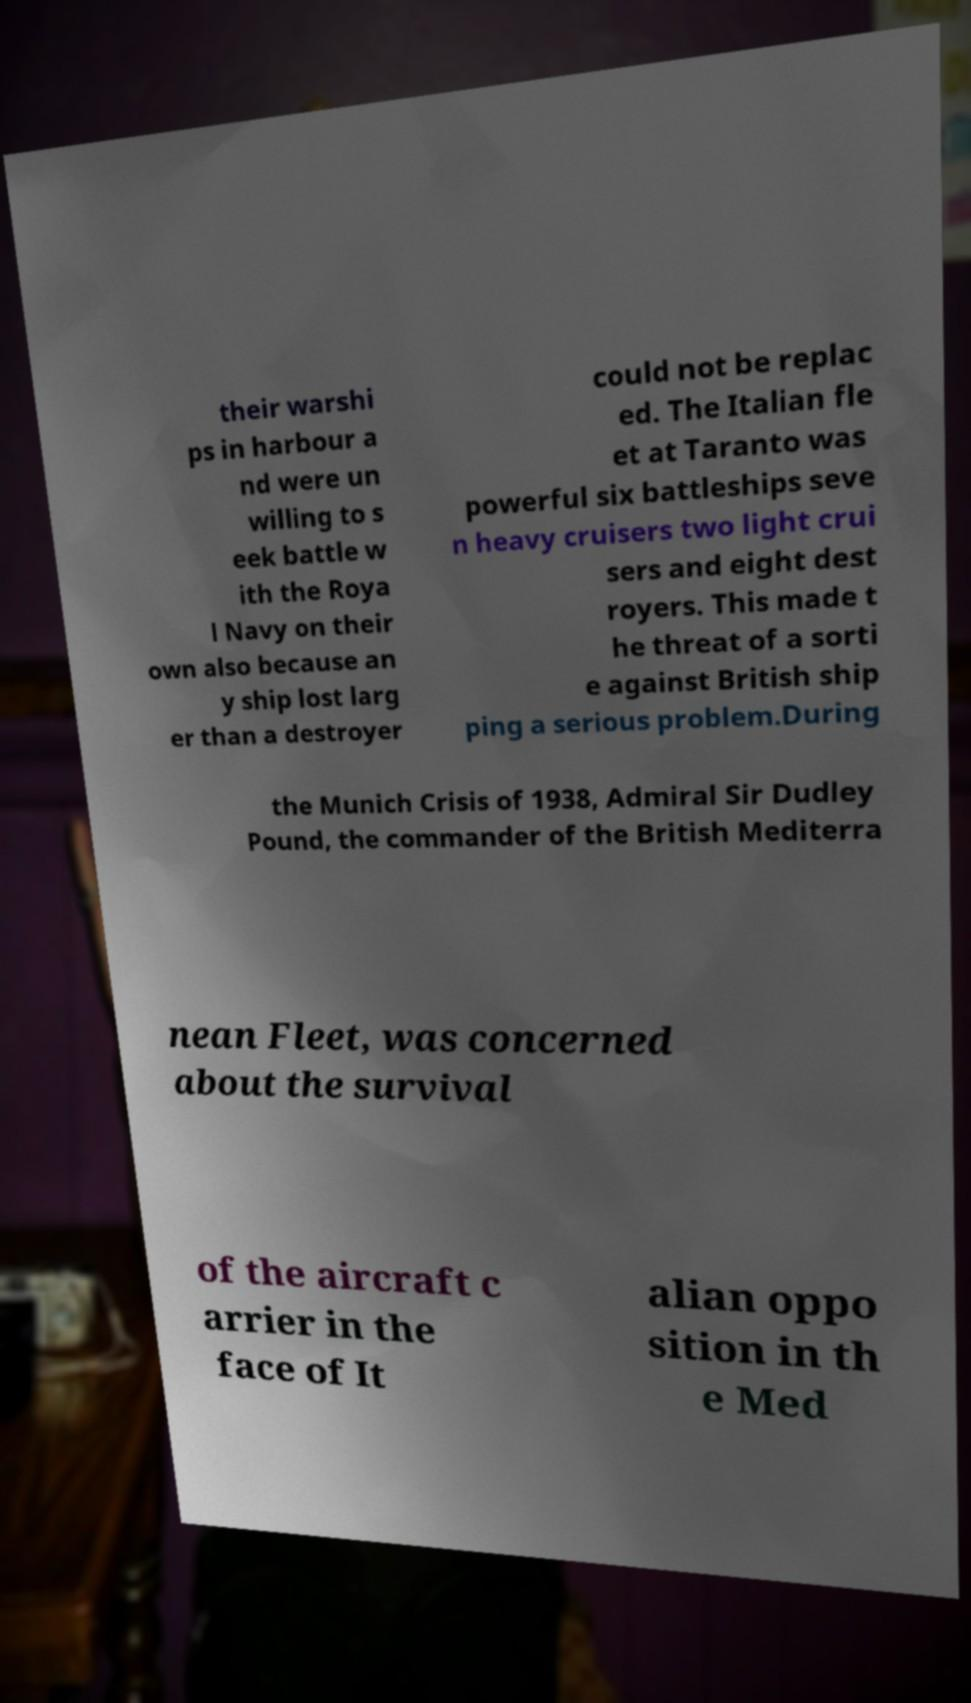For documentation purposes, I need the text within this image transcribed. Could you provide that? their warshi ps in harbour a nd were un willing to s eek battle w ith the Roya l Navy on their own also because an y ship lost larg er than a destroyer could not be replac ed. The Italian fle et at Taranto was powerful six battleships seve n heavy cruisers two light crui sers and eight dest royers. This made t he threat of a sorti e against British ship ping a serious problem.During the Munich Crisis of 1938, Admiral Sir Dudley Pound, the commander of the British Mediterra nean Fleet, was concerned about the survival of the aircraft c arrier in the face of It alian oppo sition in th e Med 